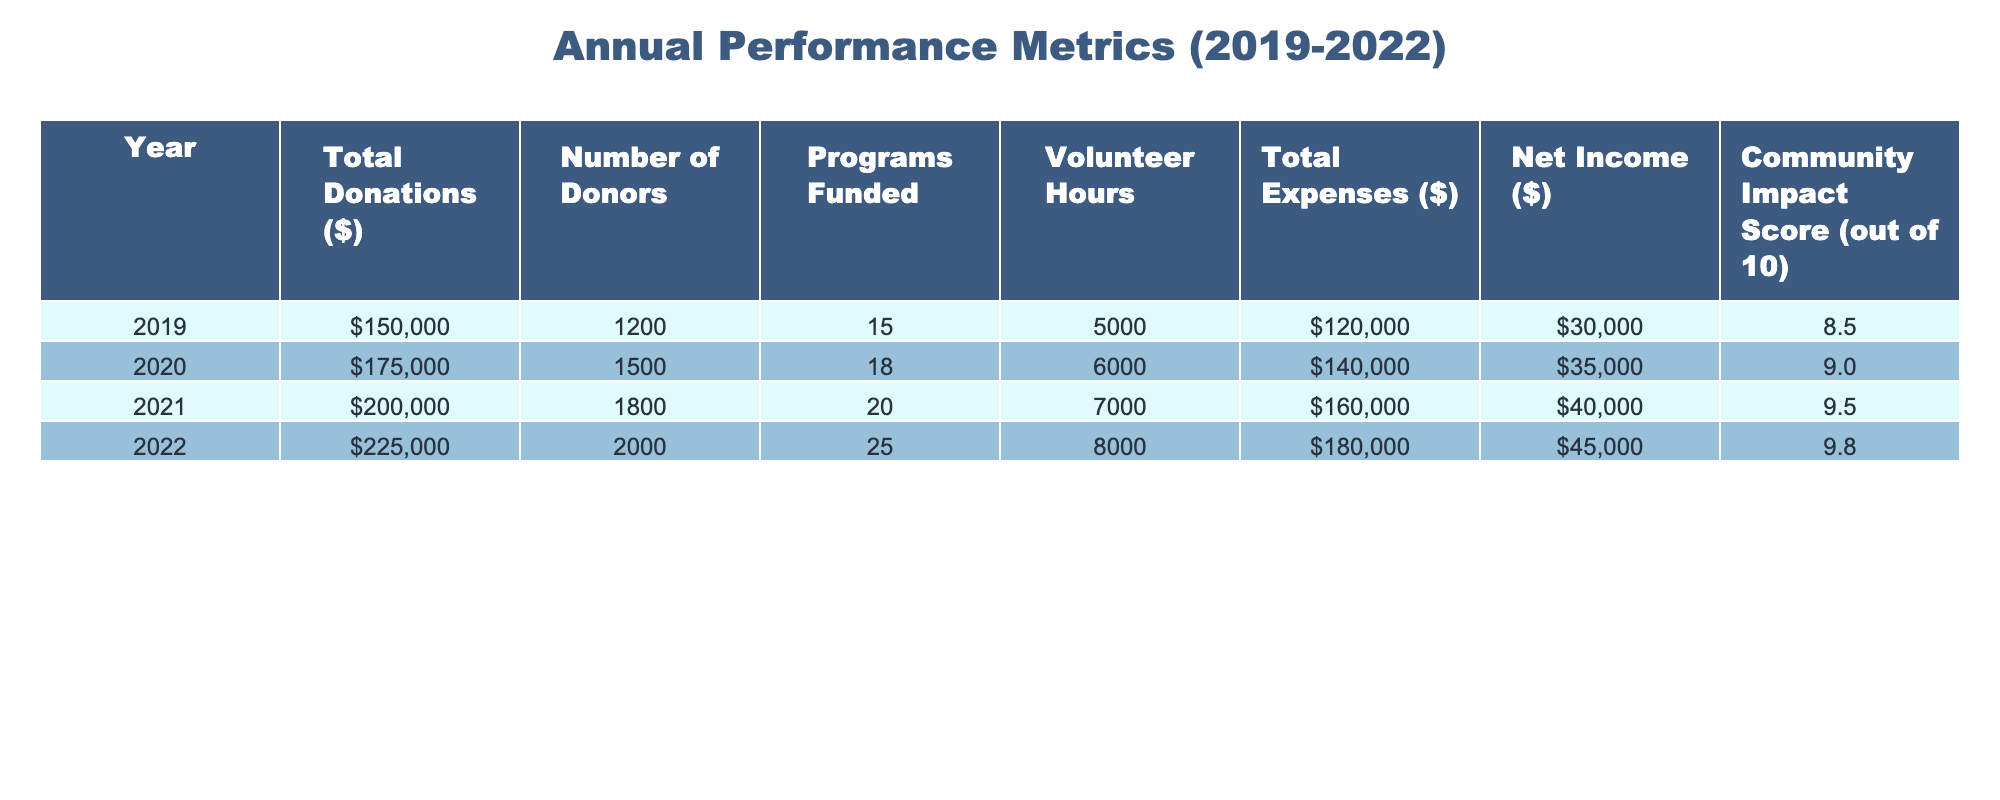What were the total donations in 2021? According to the table, the total donations for the year 2021 are $200,000.
Answer: $200,000 What was the community impact score in 2020? The community impact score for the year 2020, as listed in the table, is 9.0.
Answer: 9.0 How much did net income increase from 2019 to 2022? Net income in 2019 was $30,000 and in 2022 it was $45,000. The increase is calculated as $45,000 - $30,000 = $15,000.
Answer: $15,000 What was the average number of donors from 2019 to 2022? We sum the number of donors from each year: 1200 + 1500 + 1800 + 2000 = 7000. There are 4 years, so we divide by 4 to get the average: 7000 / 4 = 1750.
Answer: 1750 True or false: The total expenses in 2022 were higher than total donations in 2021. Total expenses in 2022 were $180,000, while total donations in 2021 were $200,000. Since $180,000 is less than $200,000, the statement is false.
Answer: False What was the increase in volunteer hours from 2019 to 2022? In 2019, volunteer hours were 5000 and in 2022 they were 8000. The increase is calculated as 8000 - 5000 = 3000.
Answer: 3000 Which year had the highest total donations and what was the amount? The year 2022 had the highest total donations at $225,000 as shown in the table.
Answer: 2022, $225,000 What percentage of total donations in 2020 came from net income? In 2020, total donations were $175,000 and net income was $35,000. To find the percentage: (35,000 / 175,000) * 100 = 20%.
Answer: 20% Which year saw the largest increase in programs funded compared to the previous year? From 2021 to 2022, programs funded increased from 20 to 25, which is a 5 program increase. This is higher than the increases in other years.
Answer: 2021 to 2022 How much total expenses did the organization incur over the four years? Adding the total expenses for each year: $120,000 + $140,000 + $160,000 + $180,000 = $600,000.
Answer: $600,000 